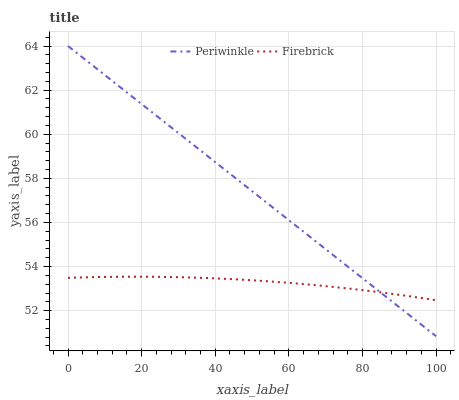Does Firebrick have the minimum area under the curve?
Answer yes or no. Yes. Does Periwinkle have the maximum area under the curve?
Answer yes or no. Yes. Does Periwinkle have the minimum area under the curve?
Answer yes or no. No. Is Periwinkle the smoothest?
Answer yes or no. Yes. Is Firebrick the roughest?
Answer yes or no. Yes. Is Periwinkle the roughest?
Answer yes or no. No. Does Periwinkle have the lowest value?
Answer yes or no. Yes. Does Periwinkle have the highest value?
Answer yes or no. Yes. Does Firebrick intersect Periwinkle?
Answer yes or no. Yes. Is Firebrick less than Periwinkle?
Answer yes or no. No. Is Firebrick greater than Periwinkle?
Answer yes or no. No. 